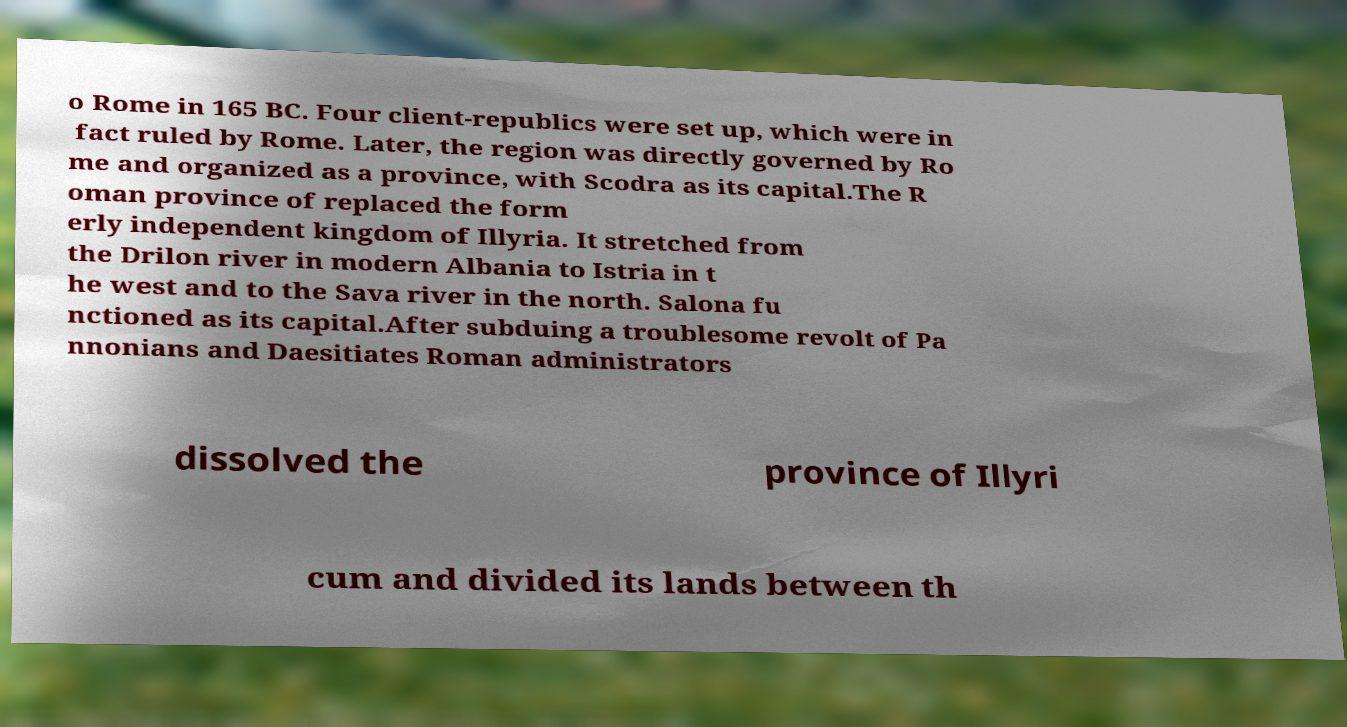Please read and relay the text visible in this image. What does it say? o Rome in 165 BC. Four client-republics were set up, which were in fact ruled by Rome. Later, the region was directly governed by Ro me and organized as a province, with Scodra as its capital.The R oman province of replaced the form erly independent kingdom of Illyria. It stretched from the Drilon river in modern Albania to Istria in t he west and to the Sava river in the north. Salona fu nctioned as its capital.After subduing a troublesome revolt of Pa nnonians and Daesitiates Roman administrators dissolved the province of Illyri cum and divided its lands between th 